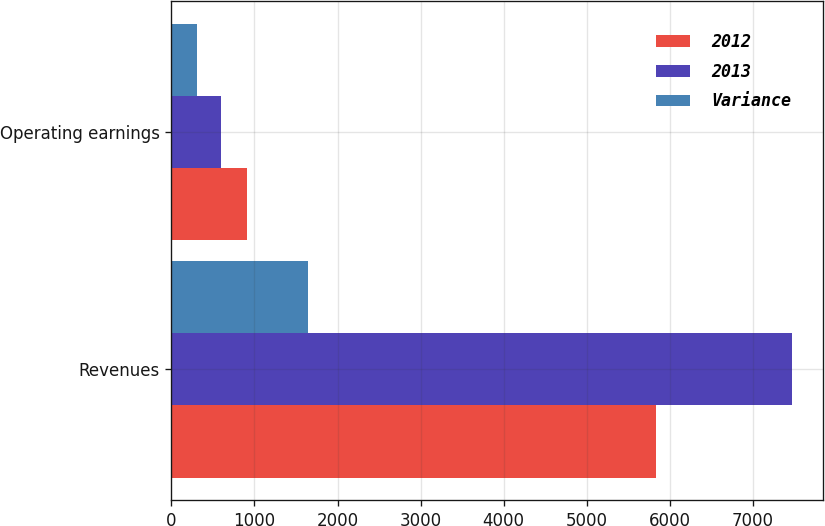Convert chart to OTSL. <chart><loc_0><loc_0><loc_500><loc_500><stacked_bar_chart><ecel><fcel>Revenues<fcel>Operating earnings<nl><fcel>2012<fcel>5832<fcel>908<nl><fcel>2013<fcel>7471<fcel>595<nl><fcel>Variance<fcel>1639<fcel>313<nl></chart> 